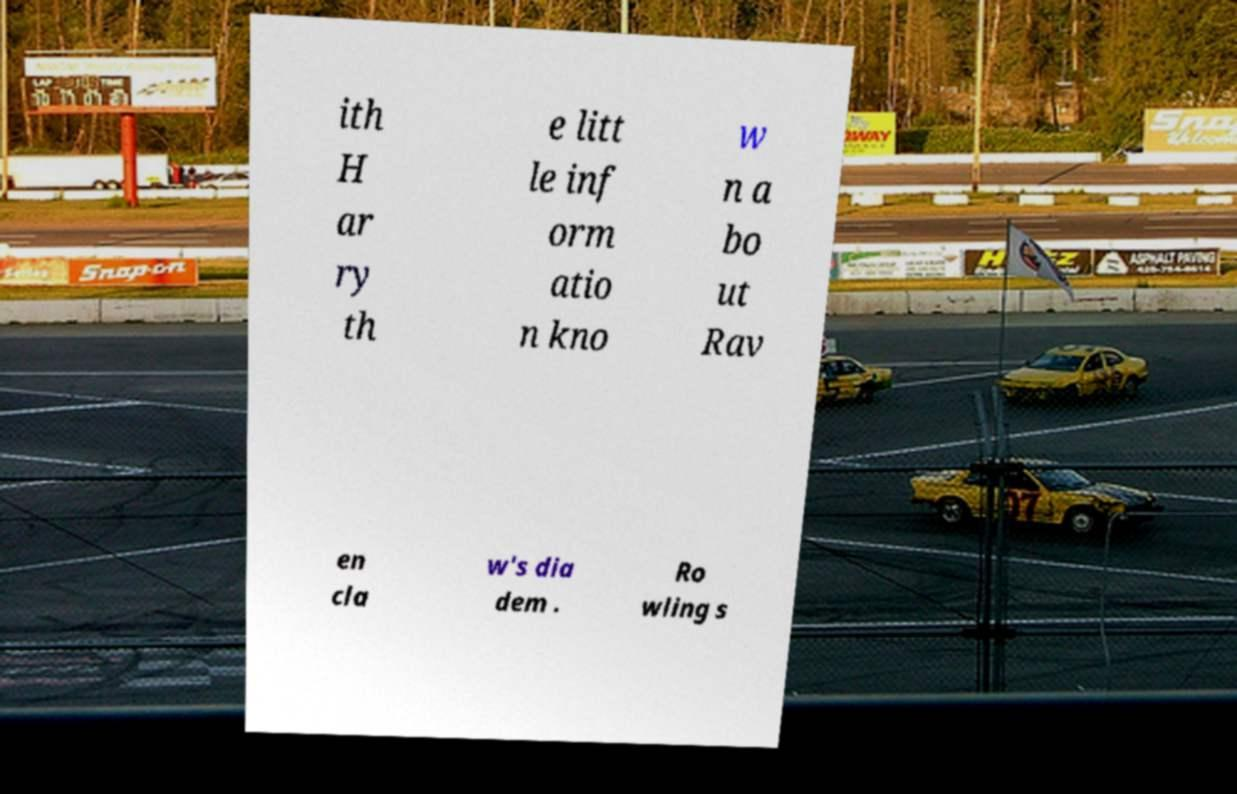Please identify and transcribe the text found in this image. ith H ar ry th e litt le inf orm atio n kno w n a bo ut Rav en cla w's dia dem . Ro wling s 